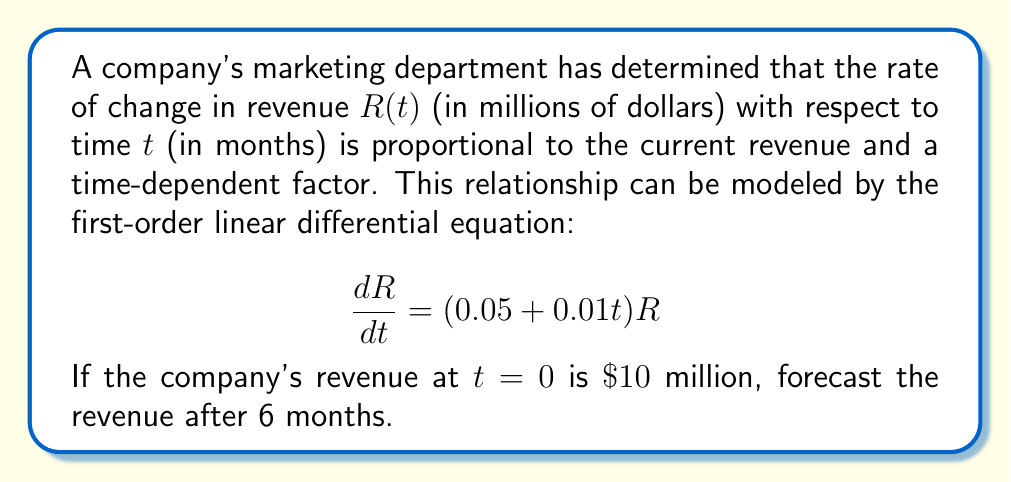Solve this math problem. To solve this problem, we need to follow these steps:

1) We have a first-order linear differential equation with variable coefficients:

   $$\frac{dR}{dt} = (0.05 + 0.01t)R$$

2) This equation can be solved using the integrating factor method. The integrating factor is:

   $$\mu(t) = e^{\int (0.05 + 0.01t) dt} = e^{0.05t + 0.005t^2}$$

3) Multiplying both sides of the original equation by $\mu(t)$:

   $$\mu(t)\frac{dR}{dt} = \mu(t)(0.05 + 0.01t)R$$

4) The left side can be rewritten as the derivative of a product:

   $$\frac{d}{dt}[\mu(t)R] = 0$$

5) Integrating both sides:

   $$\mu(t)R = C$$

   Where $C$ is a constant of integration.

6) Substituting back the expression for $\mu(t)$:

   $$R = Ce^{-0.05t - 0.005t^2}$$

7) Using the initial condition $R(0) = 10$, we can find $C$:

   $$10 = Ce^0 \implies C = 10$$

8) Therefore, the general solution is:

   $$R(t) = 10e^{0.05t + 0.005t^2}$$

9) To find the revenue after 6 months, we substitute $t = 6$:

   $$R(6) = 10e^{0.05(6) + 0.005(6^2)} = 10e^{0.3 + 0.18} = 10e^{0.48}$$

10) Calculating this value:

    $$R(6) \approx 10 * 1.6161 = 16.161$$
Answer: The forecasted revenue after 6 months is approximately $\$16.161$ million. 